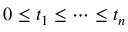<formula> <loc_0><loc_0><loc_500><loc_500>0 \leq t _ { 1 } \leq \dots \leq t _ { n }</formula> 